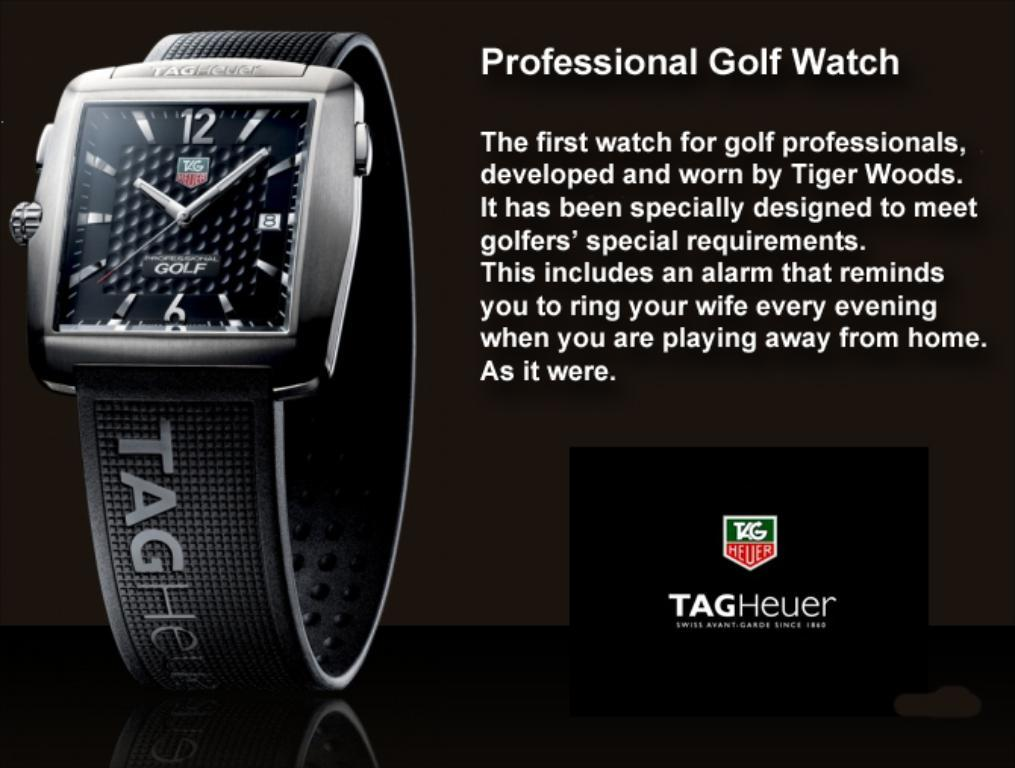<image>
Relay a brief, clear account of the picture shown. An advertisement for a professional golf watch is made by Tag Heuer. 